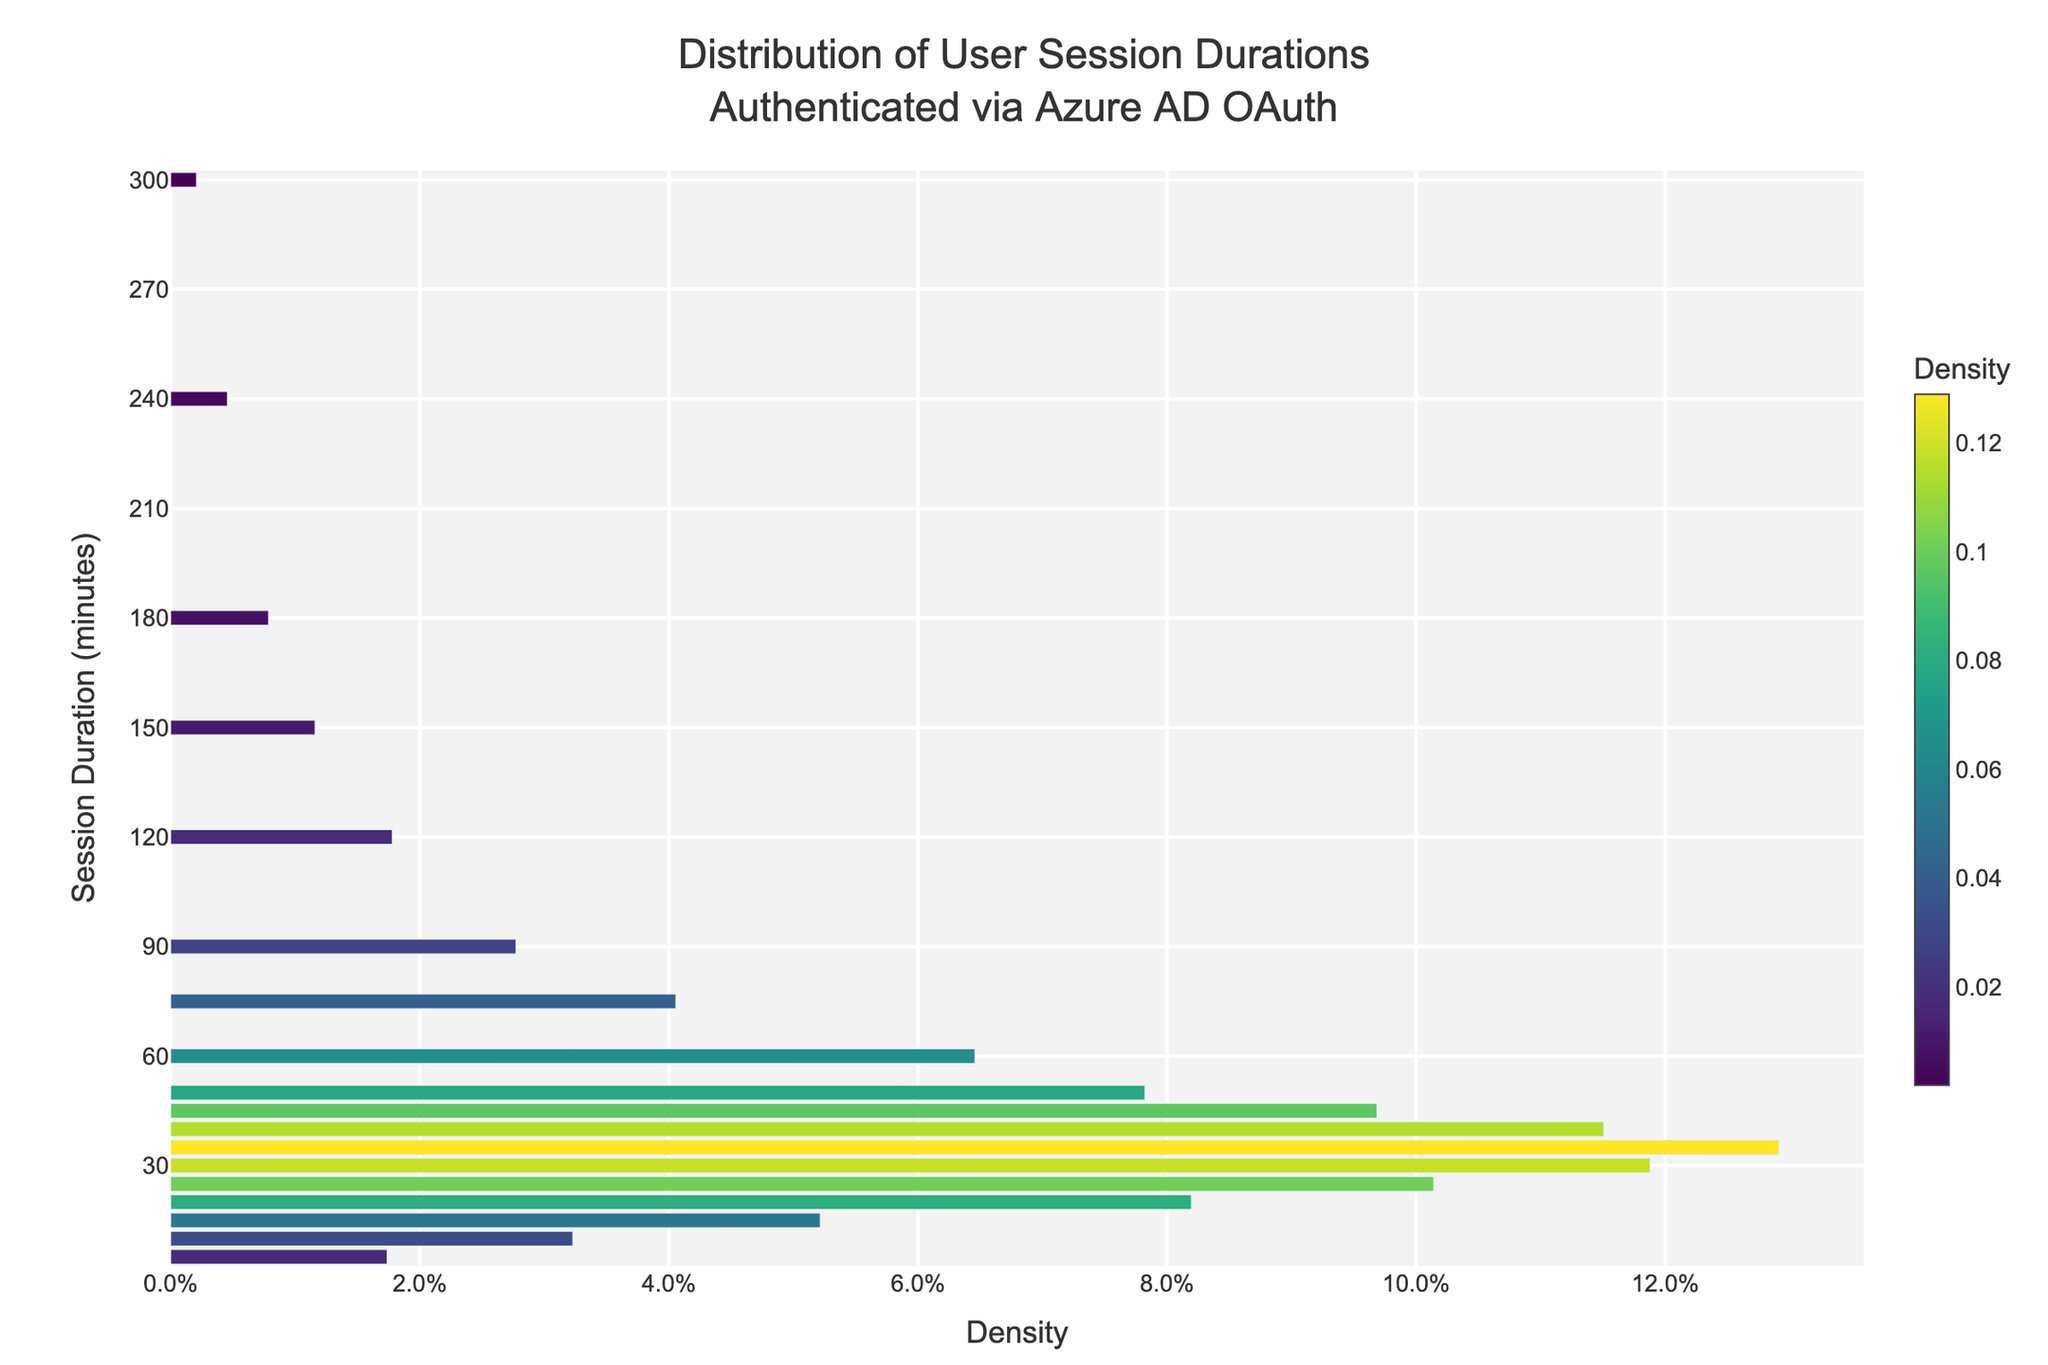What is the title of the plot? The title is located at the top center of the plot and reads "Distribution of User Session Durations Authenticated via Azure AD OAuth"
Answer: Distribution of User Session Durations Authenticated via Azure AD OAuth What is the highest session duration shown on the y-axis? The y-axis represents session duration in minutes and the highest value visible is 300
Answer: 300 minutes Which session duration has the highest density? By examining the bar that extends the furthest on the x-axis, 35 minutes has the highest density
Answer: 35 minutes What is shown on the x-axis? The x-axis shows the density of user session durations
Answer: Density What is the color scheme used in the plot? The plot utilizes the Viridis color scale, which shows a gradient from yellow to purple
Answer: Viridis How many session durations have a density above 0.1? The session durations of 15, 20, 25, 30, 35, 40, and 45 minutes have densities greater than 0.1
Answer: 7 durations Between 45 minutes and 75 minutes, which session duration has the highest density? In the interval between 45 and 75 minutes, 45 minutes has the highest density
Answer: 45 minutes What's the combined density for session durations of 60 minutes and 90 minutes? Adding the densities of 60 minutes and 90 minutes together; 60 minutes is roughly 0.0625, 90 minutes is roughly 0.0268; thus, 0.0625 + 0.0268
Answer: 0.0893 Is the density higher for session durations of 150 minutes or 180 minutes? By comparing the densities, 150 minutes has a higher density than 180 minutes
Answer: 150 minutes What pattern can you observe in the plot regarding session durations and their densities? The density increases up to a peak around 35 minutes, then gradually decreases as the session duration increases
Answer: Increase then decrease 